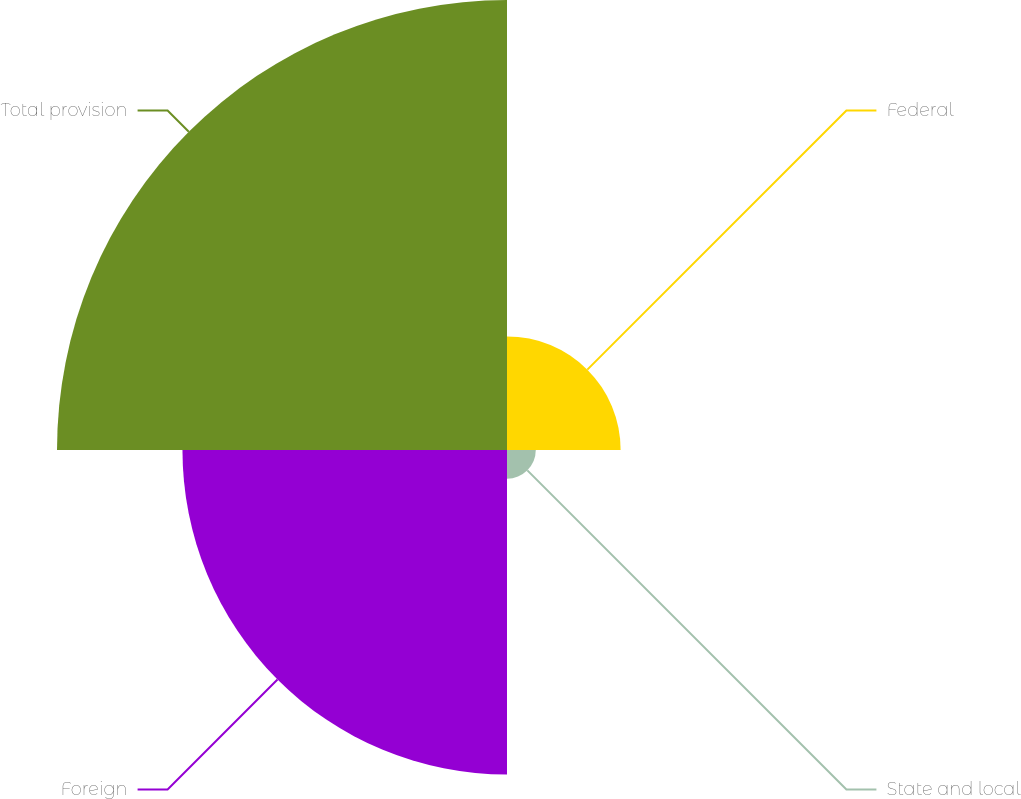Convert chart to OTSL. <chart><loc_0><loc_0><loc_500><loc_500><pie_chart><fcel>Federal<fcel>State and local<fcel>Foreign<fcel>Total provision<nl><fcel>12.39%<fcel>3.14%<fcel>35.39%<fcel>49.07%<nl></chart> 